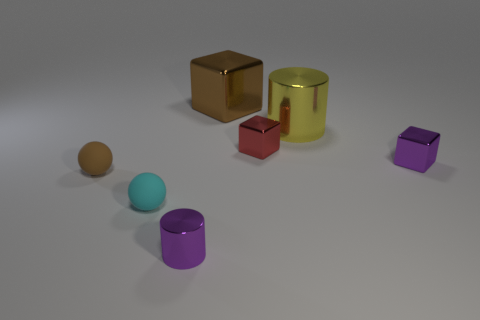Add 1 big brown matte balls. How many objects exist? 8 Subtract all small red metal cubes. How many cubes are left? 2 Subtract all spheres. How many objects are left? 5 Subtract 1 cubes. How many cubes are left? 2 Subtract all red spheres. Subtract all red cylinders. How many spheres are left? 2 Subtract all green cubes. How many purple cylinders are left? 1 Subtract all cyan matte balls. Subtract all brown things. How many objects are left? 4 Add 1 small red cubes. How many small red cubes are left? 2 Add 7 tiny spheres. How many tiny spheres exist? 9 Subtract all purple blocks. How many blocks are left? 2 